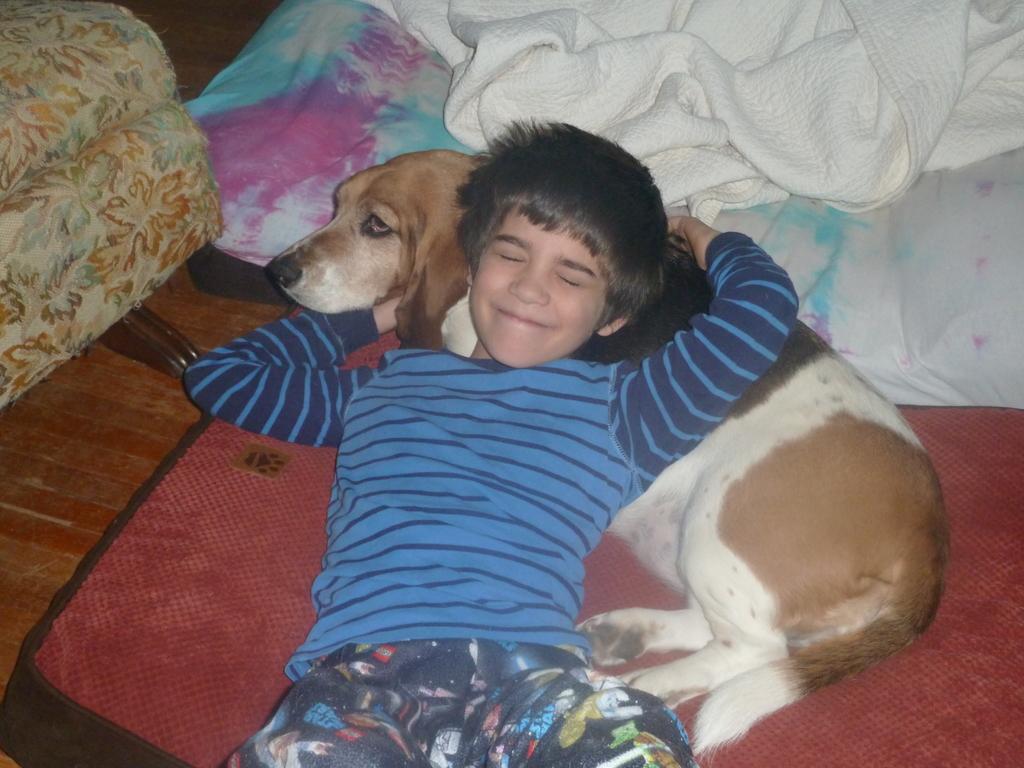How would you summarize this image in a sentence or two? In this picture we can see a boy and a dog laid on the carpet. These are blankets. 